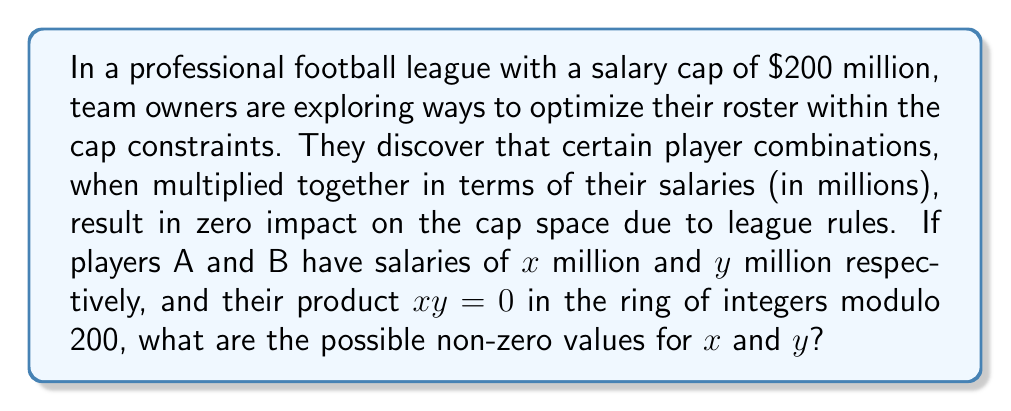Help me with this question. To solve this problem, we need to understand the concept of zero divisors in modular arithmetic and how it applies to salary cap calculations:

1) In the ring of integers modulo 200, two non-zero elements $a$ and $b$ are zero divisors if $ab \equiv 0 \pmod{200}$.

2) For this to occur, the product of $a$ and $b$ must be a multiple of 200.

3) The factors of 200 are: 1, 2, 4, 5, 8, 10, 20, 25, 40, 50, 100, 200.

4) To find non-zero pairs $(x,y)$ such that $xy \equiv 0 \pmod{200}$, we need to find pairs of these factors that multiply to give 200.

5) The possible pairs are:
   - 2 and 100
   - 4 and 50
   - 5 and 40
   - 8 and 25
   - 10 and 20

6) Therefore, the possible non-zero values for $x$ and $y$ are 2, 4, 5, 8, 10, 20, 25, 40, 50, and 100.

This concept could be used by team owners to creatively structure contracts that appear to use more cap space than they actually do, potentially allowing them to sign more high-value players while staying within the salary cap limits.
Answer: The possible non-zero values for $x$ and $y$ are 2, 4, 5, 8, 10, 20, 25, 40, 50, and 100 million dollars. 